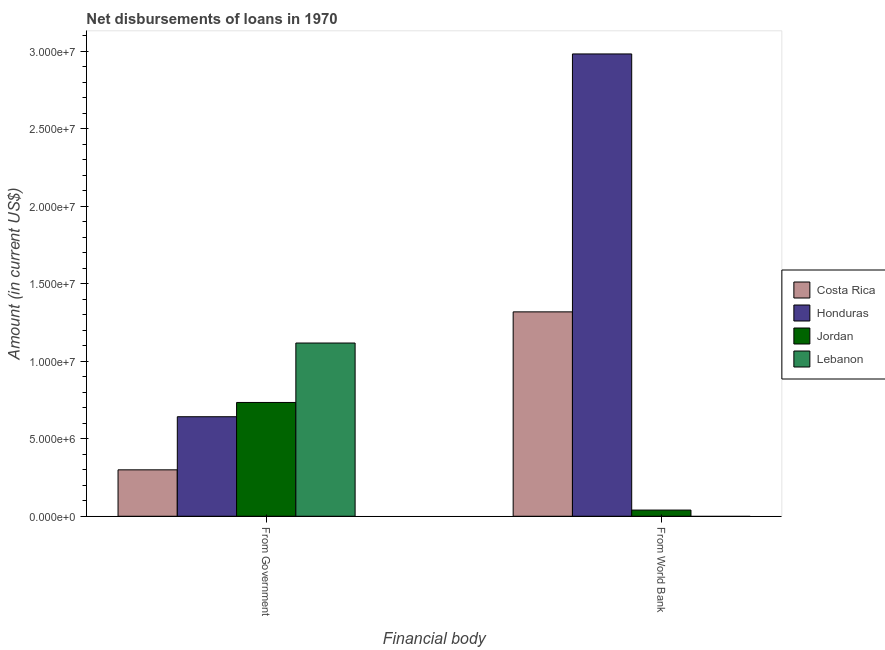How many groups of bars are there?
Ensure brevity in your answer.  2. Are the number of bars per tick equal to the number of legend labels?
Your answer should be compact. No. Are the number of bars on each tick of the X-axis equal?
Provide a short and direct response. No. How many bars are there on the 1st tick from the right?
Offer a very short reply. 3. What is the label of the 2nd group of bars from the left?
Your answer should be very brief. From World Bank. What is the net disbursements of loan from government in Honduras?
Give a very brief answer. 6.42e+06. Across all countries, what is the maximum net disbursements of loan from government?
Your answer should be compact. 1.12e+07. In which country was the net disbursements of loan from government maximum?
Provide a short and direct response. Lebanon. What is the total net disbursements of loan from government in the graph?
Keep it short and to the point. 2.79e+07. What is the difference between the net disbursements of loan from government in Lebanon and that in Honduras?
Your answer should be very brief. 4.76e+06. What is the difference between the net disbursements of loan from government in Honduras and the net disbursements of loan from world bank in Jordan?
Make the answer very short. 6.02e+06. What is the average net disbursements of loan from world bank per country?
Provide a short and direct response. 1.09e+07. What is the difference between the net disbursements of loan from world bank and net disbursements of loan from government in Jordan?
Make the answer very short. -6.95e+06. What is the ratio of the net disbursements of loan from government in Jordan to that in Costa Rica?
Ensure brevity in your answer.  2.45. In how many countries, is the net disbursements of loan from world bank greater than the average net disbursements of loan from world bank taken over all countries?
Your response must be concise. 2. Are all the bars in the graph horizontal?
Your answer should be compact. No. How many countries are there in the graph?
Provide a succinct answer. 4. What is the difference between two consecutive major ticks on the Y-axis?
Provide a succinct answer. 5.00e+06. Does the graph contain any zero values?
Offer a very short reply. Yes. How many legend labels are there?
Your answer should be compact. 4. How are the legend labels stacked?
Make the answer very short. Vertical. What is the title of the graph?
Your answer should be very brief. Net disbursements of loans in 1970. Does "Somalia" appear as one of the legend labels in the graph?
Provide a short and direct response. No. What is the label or title of the X-axis?
Provide a succinct answer. Financial body. What is the label or title of the Y-axis?
Provide a succinct answer. Amount (in current US$). What is the Amount (in current US$) in Costa Rica in From Government?
Give a very brief answer. 3.00e+06. What is the Amount (in current US$) in Honduras in From Government?
Your answer should be very brief. 6.42e+06. What is the Amount (in current US$) of Jordan in From Government?
Offer a very short reply. 7.34e+06. What is the Amount (in current US$) of Lebanon in From Government?
Your answer should be very brief. 1.12e+07. What is the Amount (in current US$) in Costa Rica in From World Bank?
Ensure brevity in your answer.  1.32e+07. What is the Amount (in current US$) of Honduras in From World Bank?
Offer a terse response. 2.98e+07. What is the Amount (in current US$) of Jordan in From World Bank?
Ensure brevity in your answer.  3.99e+05. What is the Amount (in current US$) of Lebanon in From World Bank?
Your answer should be compact. 0. Across all Financial body, what is the maximum Amount (in current US$) of Costa Rica?
Give a very brief answer. 1.32e+07. Across all Financial body, what is the maximum Amount (in current US$) in Honduras?
Offer a very short reply. 2.98e+07. Across all Financial body, what is the maximum Amount (in current US$) in Jordan?
Your answer should be very brief. 7.34e+06. Across all Financial body, what is the maximum Amount (in current US$) of Lebanon?
Give a very brief answer. 1.12e+07. Across all Financial body, what is the minimum Amount (in current US$) of Costa Rica?
Your response must be concise. 3.00e+06. Across all Financial body, what is the minimum Amount (in current US$) in Honduras?
Your answer should be very brief. 6.42e+06. Across all Financial body, what is the minimum Amount (in current US$) of Jordan?
Your answer should be very brief. 3.99e+05. Across all Financial body, what is the minimum Amount (in current US$) of Lebanon?
Give a very brief answer. 0. What is the total Amount (in current US$) of Costa Rica in the graph?
Provide a short and direct response. 1.62e+07. What is the total Amount (in current US$) in Honduras in the graph?
Your response must be concise. 3.63e+07. What is the total Amount (in current US$) in Jordan in the graph?
Ensure brevity in your answer.  7.74e+06. What is the total Amount (in current US$) of Lebanon in the graph?
Give a very brief answer. 1.12e+07. What is the difference between the Amount (in current US$) in Costa Rica in From Government and that in From World Bank?
Ensure brevity in your answer.  -1.02e+07. What is the difference between the Amount (in current US$) in Honduras in From Government and that in From World Bank?
Your response must be concise. -2.34e+07. What is the difference between the Amount (in current US$) of Jordan in From Government and that in From World Bank?
Make the answer very short. 6.95e+06. What is the difference between the Amount (in current US$) in Costa Rica in From Government and the Amount (in current US$) in Honduras in From World Bank?
Give a very brief answer. -2.68e+07. What is the difference between the Amount (in current US$) of Costa Rica in From Government and the Amount (in current US$) of Jordan in From World Bank?
Offer a terse response. 2.60e+06. What is the difference between the Amount (in current US$) in Honduras in From Government and the Amount (in current US$) in Jordan in From World Bank?
Keep it short and to the point. 6.02e+06. What is the average Amount (in current US$) of Costa Rica per Financial body?
Offer a very short reply. 8.09e+06. What is the average Amount (in current US$) in Honduras per Financial body?
Provide a succinct answer. 1.81e+07. What is the average Amount (in current US$) in Jordan per Financial body?
Your response must be concise. 3.87e+06. What is the average Amount (in current US$) in Lebanon per Financial body?
Provide a succinct answer. 5.59e+06. What is the difference between the Amount (in current US$) of Costa Rica and Amount (in current US$) of Honduras in From Government?
Your answer should be very brief. -3.43e+06. What is the difference between the Amount (in current US$) in Costa Rica and Amount (in current US$) in Jordan in From Government?
Offer a terse response. -4.35e+06. What is the difference between the Amount (in current US$) in Costa Rica and Amount (in current US$) in Lebanon in From Government?
Give a very brief answer. -8.18e+06. What is the difference between the Amount (in current US$) of Honduras and Amount (in current US$) of Jordan in From Government?
Ensure brevity in your answer.  -9.21e+05. What is the difference between the Amount (in current US$) in Honduras and Amount (in current US$) in Lebanon in From Government?
Make the answer very short. -4.76e+06. What is the difference between the Amount (in current US$) of Jordan and Amount (in current US$) of Lebanon in From Government?
Provide a succinct answer. -3.84e+06. What is the difference between the Amount (in current US$) of Costa Rica and Amount (in current US$) of Honduras in From World Bank?
Offer a terse response. -1.66e+07. What is the difference between the Amount (in current US$) in Costa Rica and Amount (in current US$) in Jordan in From World Bank?
Your answer should be compact. 1.28e+07. What is the difference between the Amount (in current US$) of Honduras and Amount (in current US$) of Jordan in From World Bank?
Your response must be concise. 2.94e+07. What is the ratio of the Amount (in current US$) in Costa Rica in From Government to that in From World Bank?
Keep it short and to the point. 0.23. What is the ratio of the Amount (in current US$) in Honduras in From Government to that in From World Bank?
Ensure brevity in your answer.  0.22. What is the ratio of the Amount (in current US$) of Jordan in From Government to that in From World Bank?
Your answer should be compact. 18.41. What is the difference between the highest and the second highest Amount (in current US$) of Costa Rica?
Your answer should be very brief. 1.02e+07. What is the difference between the highest and the second highest Amount (in current US$) in Honduras?
Your answer should be compact. 2.34e+07. What is the difference between the highest and the second highest Amount (in current US$) of Jordan?
Ensure brevity in your answer.  6.95e+06. What is the difference between the highest and the lowest Amount (in current US$) in Costa Rica?
Provide a short and direct response. 1.02e+07. What is the difference between the highest and the lowest Amount (in current US$) of Honduras?
Provide a succinct answer. 2.34e+07. What is the difference between the highest and the lowest Amount (in current US$) in Jordan?
Offer a terse response. 6.95e+06. What is the difference between the highest and the lowest Amount (in current US$) in Lebanon?
Ensure brevity in your answer.  1.12e+07. 